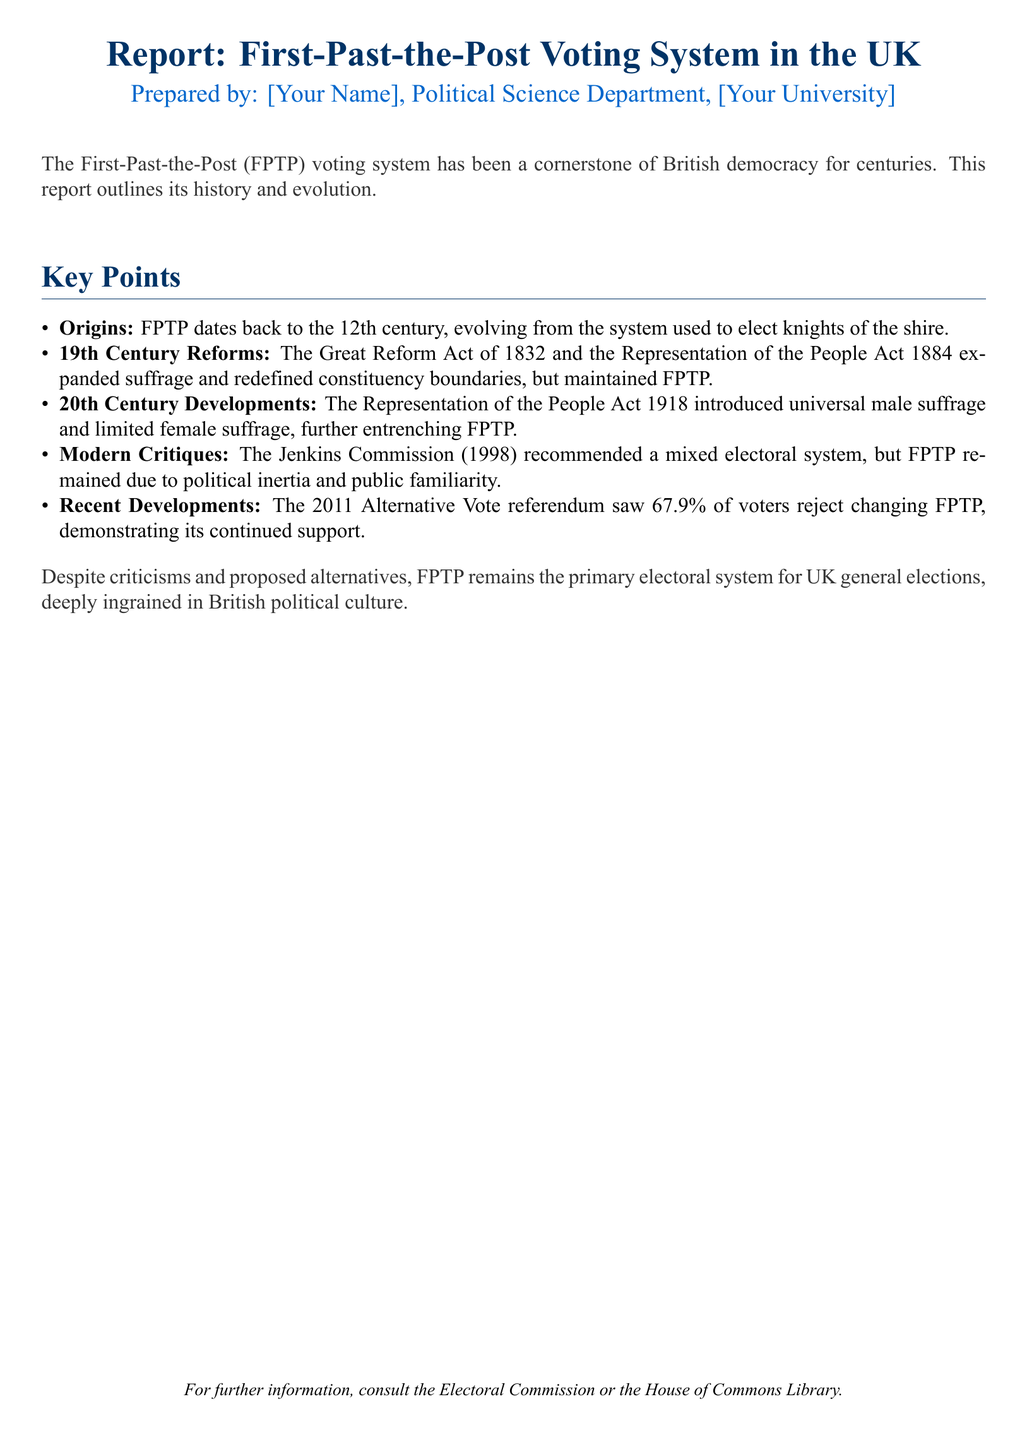What is the title of the report? The title of the report is stated at the beginning of the document.
Answer: Report: First-Past-the-Post Voting System in the UK Who prepared the report? The report specifies the author's name and department.
Answer: [Your Name], Political Science Department In what century did the FPTP voting system originate? The origins of the FPTP system are noted in the document.
Answer: 12th century What significant act in the 19th century expanded suffrage? The document mentions an important legislative act that expanded voting rights.
Answer: The Great Reform Act of 1832 What percentage of voters rejected the Alternative Vote in 2011? The document provides specific statistics regarding the referendum outcome.
Answer: 67.9% What commission recommended a mixed electoral system? The report references a commission that suggested changing the voting system.
Answer: Jenkins Commission What type of voting system remains the primary electoral system in the UK? The document explicitly states the current electoral system in use.
Answer: First-Past-the-Post (FPTP) What body offers further information according to the report? The conclusion of the document suggests where to find more information.
Answer: Electoral Commission or the House of Commons Library 